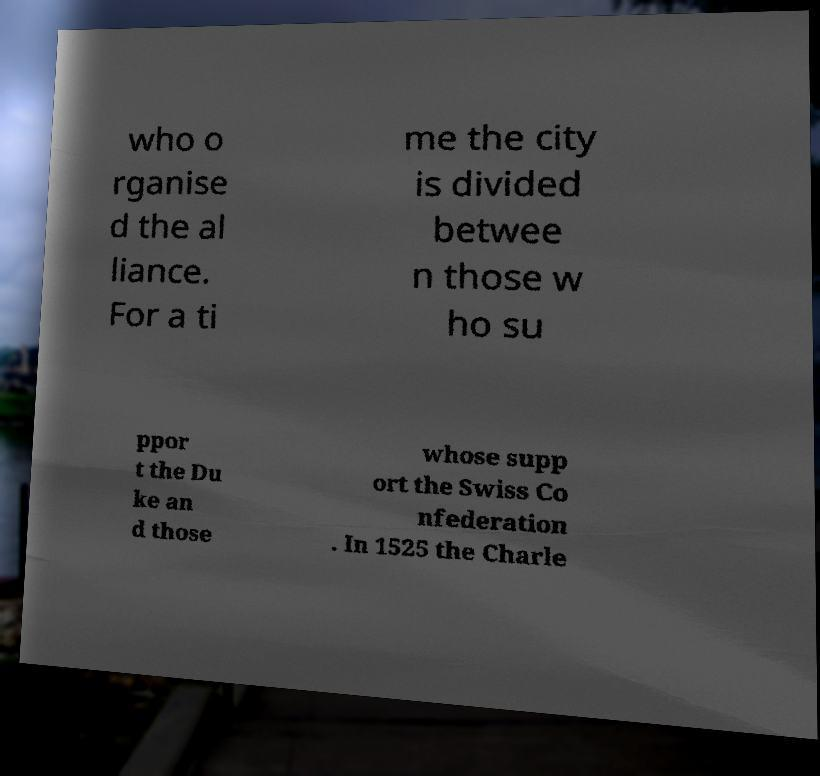Could you extract and type out the text from this image? who o rganise d the al liance. For a ti me the city is divided betwee n those w ho su ppor t the Du ke an d those whose supp ort the Swiss Co nfederation . In 1525 the Charle 